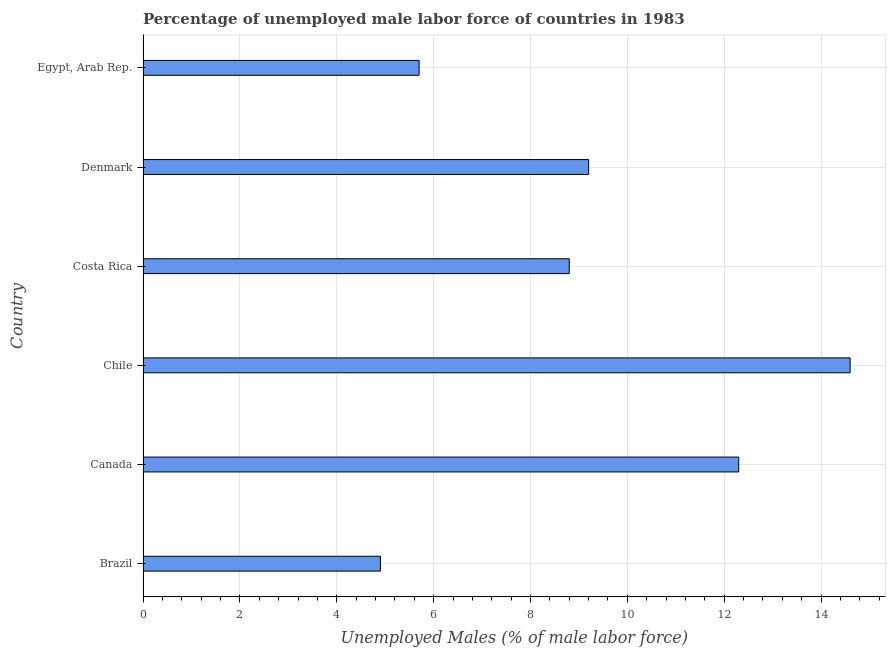Does the graph contain any zero values?
Keep it short and to the point. No. Does the graph contain grids?
Make the answer very short. Yes. What is the title of the graph?
Provide a short and direct response. Percentage of unemployed male labor force of countries in 1983. What is the label or title of the X-axis?
Provide a succinct answer. Unemployed Males (% of male labor force). What is the total unemployed male labour force in Egypt, Arab Rep.?
Ensure brevity in your answer.  5.7. Across all countries, what is the maximum total unemployed male labour force?
Your answer should be compact. 14.6. Across all countries, what is the minimum total unemployed male labour force?
Make the answer very short. 4.9. In which country was the total unemployed male labour force maximum?
Your answer should be compact. Chile. What is the sum of the total unemployed male labour force?
Offer a terse response. 55.5. What is the average total unemployed male labour force per country?
Offer a very short reply. 9.25. What is the ratio of the total unemployed male labour force in Chile to that in Egypt, Arab Rep.?
Provide a succinct answer. 2.56. Is the total unemployed male labour force in Costa Rica less than that in Egypt, Arab Rep.?
Your response must be concise. No. Is the difference between the total unemployed male labour force in Canada and Egypt, Arab Rep. greater than the difference between any two countries?
Your answer should be very brief. No. Are all the bars in the graph horizontal?
Keep it short and to the point. Yes. Are the values on the major ticks of X-axis written in scientific E-notation?
Ensure brevity in your answer.  No. What is the Unemployed Males (% of male labor force) of Brazil?
Make the answer very short. 4.9. What is the Unemployed Males (% of male labor force) in Canada?
Your answer should be compact. 12.3. What is the Unemployed Males (% of male labor force) in Chile?
Give a very brief answer. 14.6. What is the Unemployed Males (% of male labor force) of Costa Rica?
Provide a succinct answer. 8.8. What is the Unemployed Males (% of male labor force) of Denmark?
Your answer should be compact. 9.2. What is the Unemployed Males (% of male labor force) of Egypt, Arab Rep.?
Your answer should be compact. 5.7. What is the difference between the Unemployed Males (% of male labor force) in Brazil and Canada?
Ensure brevity in your answer.  -7.4. What is the difference between the Unemployed Males (% of male labor force) in Brazil and Chile?
Keep it short and to the point. -9.7. What is the difference between the Unemployed Males (% of male labor force) in Brazil and Costa Rica?
Your response must be concise. -3.9. What is the difference between the Unemployed Males (% of male labor force) in Brazil and Egypt, Arab Rep.?
Provide a short and direct response. -0.8. What is the difference between the Unemployed Males (% of male labor force) in Canada and Costa Rica?
Your response must be concise. 3.5. What is the difference between the Unemployed Males (% of male labor force) in Canada and Denmark?
Provide a short and direct response. 3.1. What is the difference between the Unemployed Males (% of male labor force) in Chile and Egypt, Arab Rep.?
Keep it short and to the point. 8.9. What is the difference between the Unemployed Males (% of male labor force) in Costa Rica and Denmark?
Your response must be concise. -0.4. What is the difference between the Unemployed Males (% of male labor force) in Denmark and Egypt, Arab Rep.?
Offer a terse response. 3.5. What is the ratio of the Unemployed Males (% of male labor force) in Brazil to that in Canada?
Offer a very short reply. 0.4. What is the ratio of the Unemployed Males (% of male labor force) in Brazil to that in Chile?
Make the answer very short. 0.34. What is the ratio of the Unemployed Males (% of male labor force) in Brazil to that in Costa Rica?
Offer a very short reply. 0.56. What is the ratio of the Unemployed Males (% of male labor force) in Brazil to that in Denmark?
Keep it short and to the point. 0.53. What is the ratio of the Unemployed Males (% of male labor force) in Brazil to that in Egypt, Arab Rep.?
Provide a short and direct response. 0.86. What is the ratio of the Unemployed Males (% of male labor force) in Canada to that in Chile?
Provide a short and direct response. 0.84. What is the ratio of the Unemployed Males (% of male labor force) in Canada to that in Costa Rica?
Offer a very short reply. 1.4. What is the ratio of the Unemployed Males (% of male labor force) in Canada to that in Denmark?
Your answer should be compact. 1.34. What is the ratio of the Unemployed Males (% of male labor force) in Canada to that in Egypt, Arab Rep.?
Provide a short and direct response. 2.16. What is the ratio of the Unemployed Males (% of male labor force) in Chile to that in Costa Rica?
Offer a terse response. 1.66. What is the ratio of the Unemployed Males (% of male labor force) in Chile to that in Denmark?
Give a very brief answer. 1.59. What is the ratio of the Unemployed Males (% of male labor force) in Chile to that in Egypt, Arab Rep.?
Your response must be concise. 2.56. What is the ratio of the Unemployed Males (% of male labor force) in Costa Rica to that in Denmark?
Offer a terse response. 0.96. What is the ratio of the Unemployed Males (% of male labor force) in Costa Rica to that in Egypt, Arab Rep.?
Offer a very short reply. 1.54. What is the ratio of the Unemployed Males (% of male labor force) in Denmark to that in Egypt, Arab Rep.?
Your response must be concise. 1.61. 